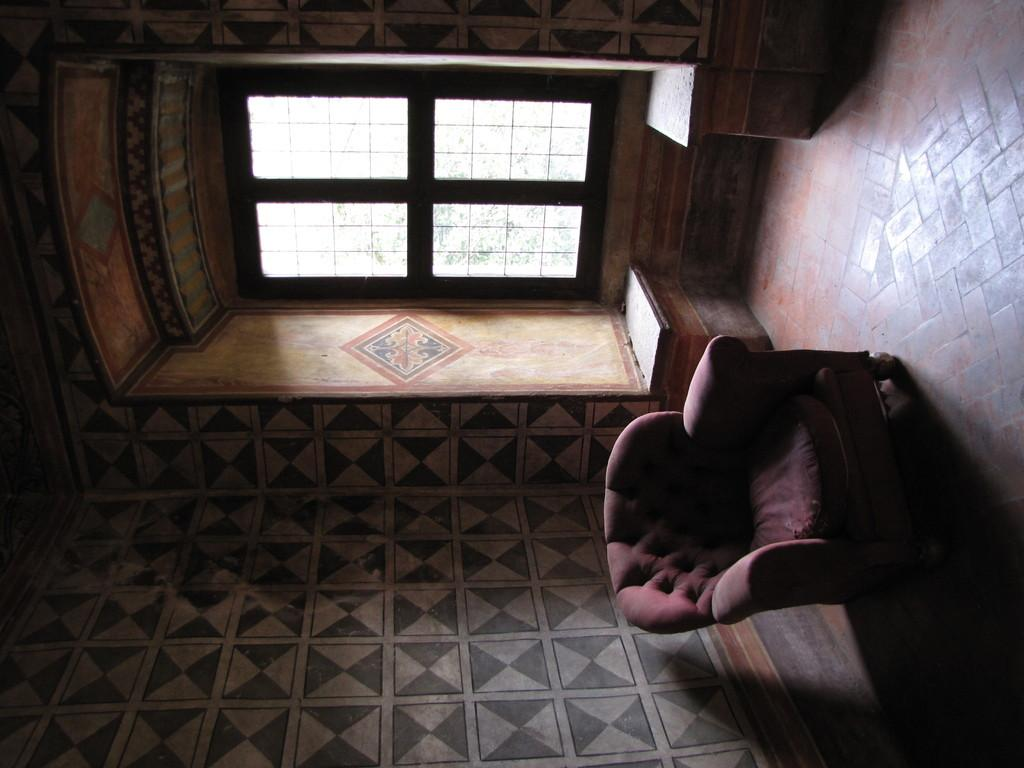What type of furniture is in the image? There is a couch in the image. What can be seen through the window in the image? The fact does not provide information about what can be seen through the window. What is the background of the image made of? There is a wall in the image, which serves as the background. What type of bell can be heard ringing in the image? There is no bell present in the image, and therefore no sound can be heard. 